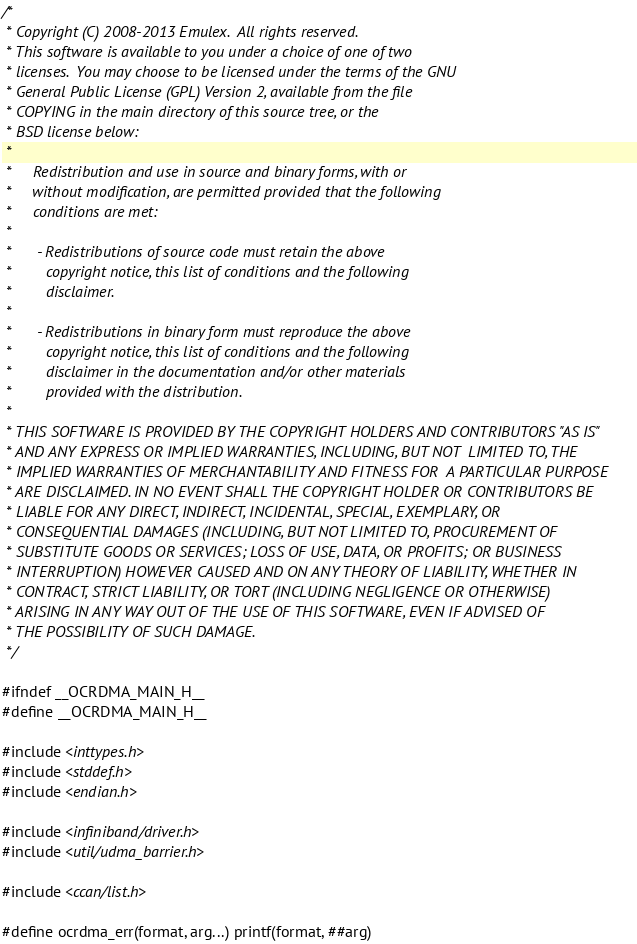<code> <loc_0><loc_0><loc_500><loc_500><_C_>/*
 * Copyright (C) 2008-2013 Emulex.  All rights reserved.
 * This software is available to you under a choice of one of two
 * licenses.  You may choose to be licensed under the terms of the GNU
 * General Public License (GPL) Version 2, available from the file
 * COPYING in the main directory of this source tree, or the
 * BSD license below:
 *
 *     Redistribution and use in source and binary forms, with or
 *     without modification, are permitted provided that the following
 *     conditions are met:
 *
 *      - Redistributions of source code must retain the above
 *        copyright notice, this list of conditions and the following
 *        disclaimer.
 *
 *      - Redistributions in binary form must reproduce the above
 *        copyright notice, this list of conditions and the following
 *        disclaimer in the documentation and/or other materials
 *        provided with the distribution.
 *
 * THIS SOFTWARE IS PROVIDED BY THE COPYRIGHT HOLDERS AND CONTRIBUTORS "AS IS"
 * AND ANY EXPRESS OR IMPLIED WARRANTIES, INCLUDING, BUT NOT  LIMITED TO, THE
 * IMPLIED WARRANTIES OF MERCHANTABILITY AND FITNESS FOR  A PARTICULAR PURPOSE
 * ARE DISCLAIMED. IN NO EVENT SHALL THE COPYRIGHT HOLDER OR CONTRIBUTORS BE
 * LIABLE FOR ANY DIRECT, INDIRECT, INCIDENTAL, SPECIAL, EXEMPLARY, OR
 * CONSEQUENTIAL DAMAGES (INCLUDING, BUT NOT LIMITED TO, PROCUREMENT OF
 * SUBSTITUTE GOODS OR SERVICES; LOSS OF USE, DATA, OR PROFITS; OR BUSINESS
 * INTERRUPTION) HOWEVER CAUSED AND ON ANY THEORY OF LIABILITY, WHETHER IN
 * CONTRACT, STRICT LIABILITY, OR TORT (INCLUDING NEGLIGENCE OR OTHERWISE)
 * ARISING IN ANY WAY OUT OF THE USE OF THIS SOFTWARE, EVEN IF ADVISED OF
 * THE POSSIBILITY OF SUCH DAMAGE.
 */

#ifndef __OCRDMA_MAIN_H__
#define __OCRDMA_MAIN_H__

#include <inttypes.h>
#include <stddef.h>
#include <endian.h>

#include <infiniband/driver.h>
#include <util/udma_barrier.h>

#include <ccan/list.h>

#define ocrdma_err(format, arg...) printf(format, ##arg)
</code> 